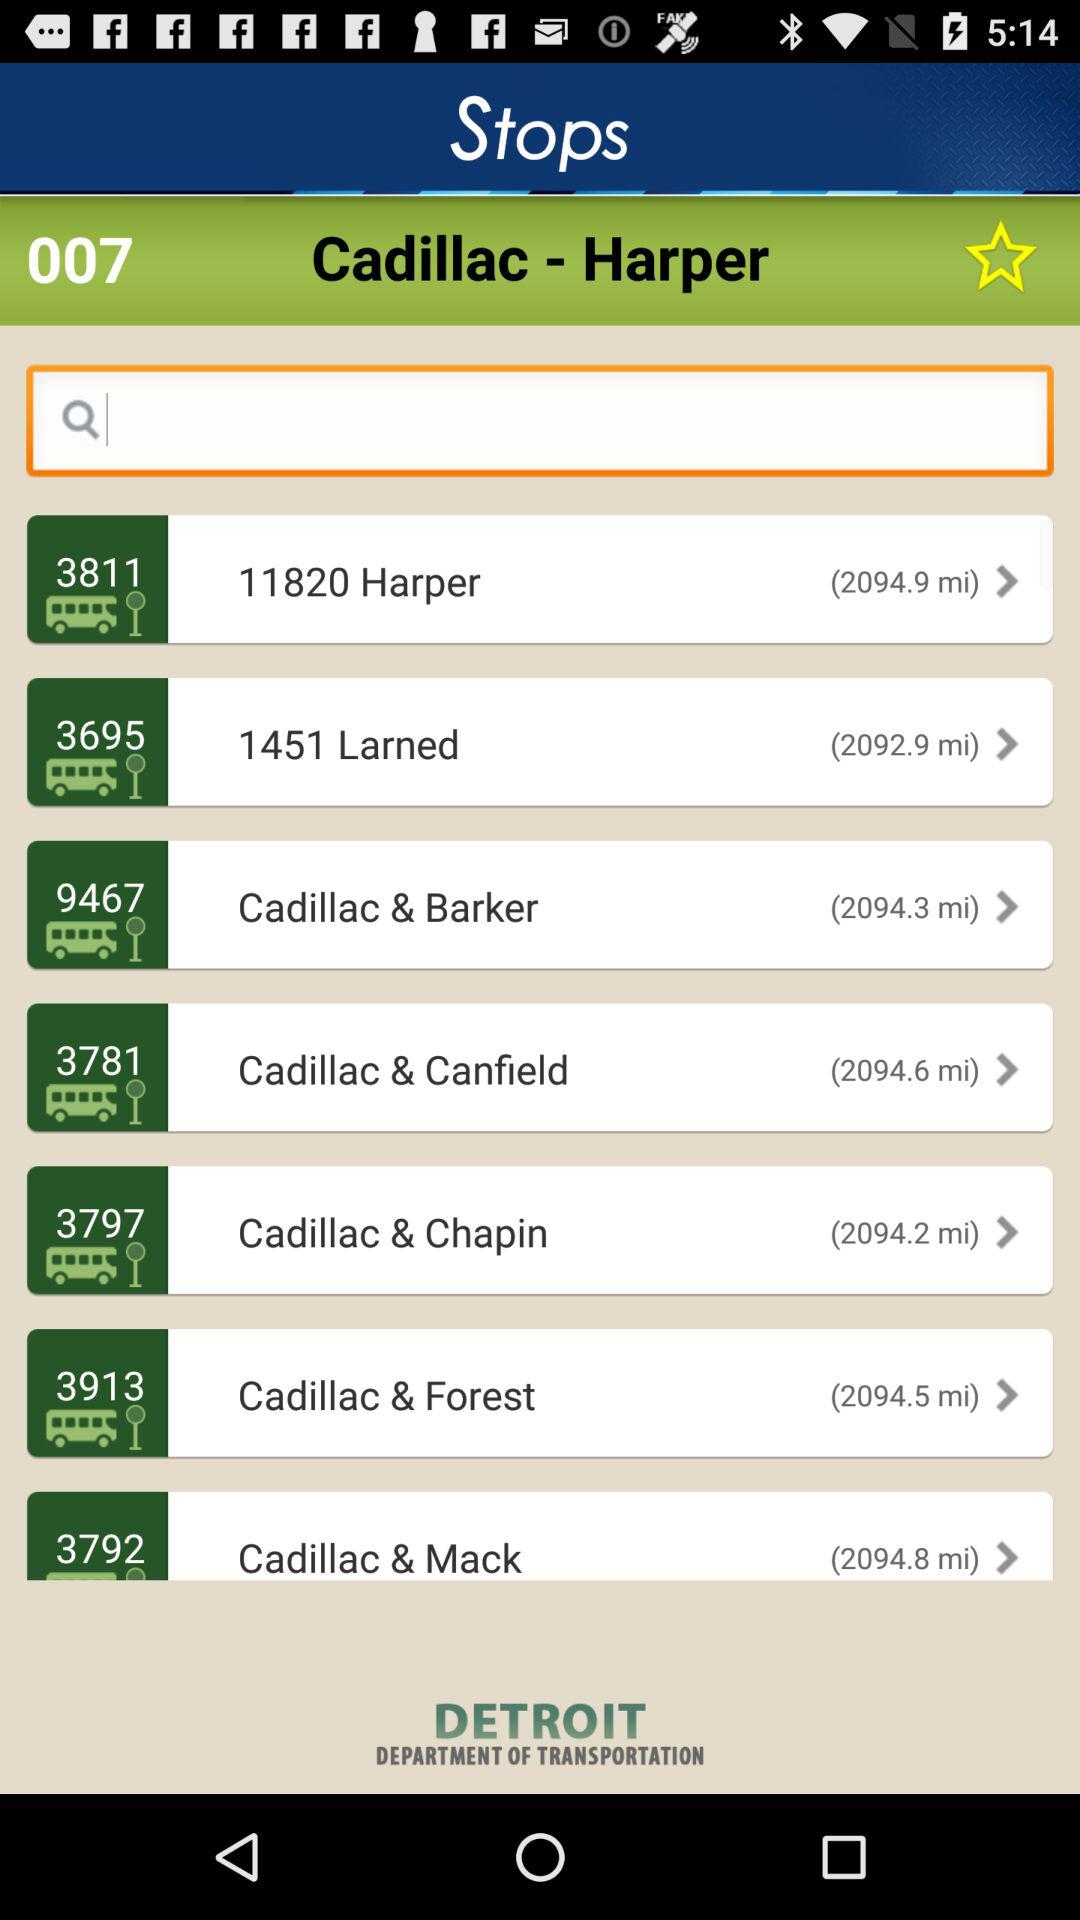How far away is Cadillac & Barker? It is 2094.3 miles away. 